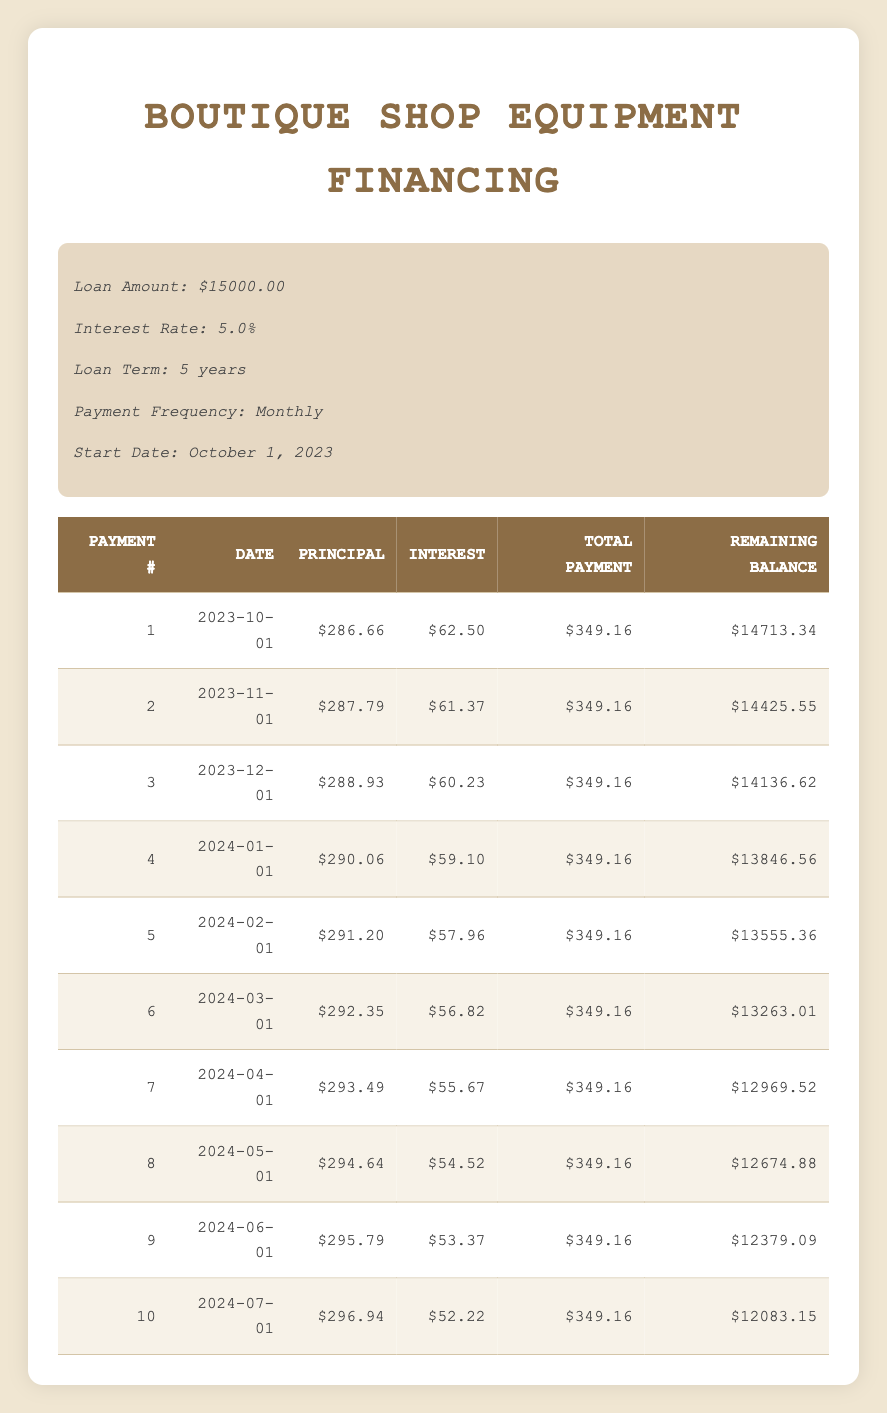What is the total payment for the first month? The first month's total payment is listed in the table under the "Total Payment" column for Payment Number 1. It reads 349.16.
Answer: 349.16 How much of the second payment goes towards the principal? The amount allocated to the principal for the second payment is found in the "Principal" column for Payment Number 2, which is 287.79.
Answer: 287.79 What is the remaining balance after the third payment? The remaining balance after the third payment is displayed in the "Remaining Balance" column for Payment Number 3, which is 14136.62.
Answer: 14136.62 Is the interest paid in the tenth payment less than 55 dollars? Checking the "Interest" column for Payment Number 10, the interest paid is 52.22, which is less than 55 dollars.
Answer: Yes What is the total principal paid after the first five payments? To find the total principal paid after five payments, sum the principal payments for the first five entries: (286.66 + 287.79 + 288.93 + 290.06 + 291.20) = 1444.64.
Answer: 1444.64 What is the average total payment made in the first ten months? To calculate the average total payment over the first ten payments, add all the total payments: (349.16 * 10) = 3491.60, then divide by 10 which equals 349.16.
Answer: 349.16 Which payment number has the highest principal payment? By reviewing the "Principal" column for all payment numbers, Payment Number 6 has the highest principal payment at 292.35.
Answer: 6 What is the total interest paid in the first month compared to the second month? The interest paid in the first month is listed as 62.50, and for the second month, it is 61.37. To compare, 62.50 is greater than 61.37.
Answer: First month is greater How much total is left to be paid after the seventh payment? The remaining balance following the seventh payment is 12969.52, as displayed in the "Remaining Balance" column for Payment Number 7.
Answer: 12969.52 After how many payments will the remaining balance fall below 13000? By checking the "Remaining Balance" column, after the eighth payment, the balance will be 12674.88, which is below 13000. Therefore, it will drop below 13000 after 8 payments.
Answer: 8 